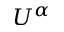Convert formula to latex. <formula><loc_0><loc_0><loc_500><loc_500>U ^ { \alpha }</formula> 